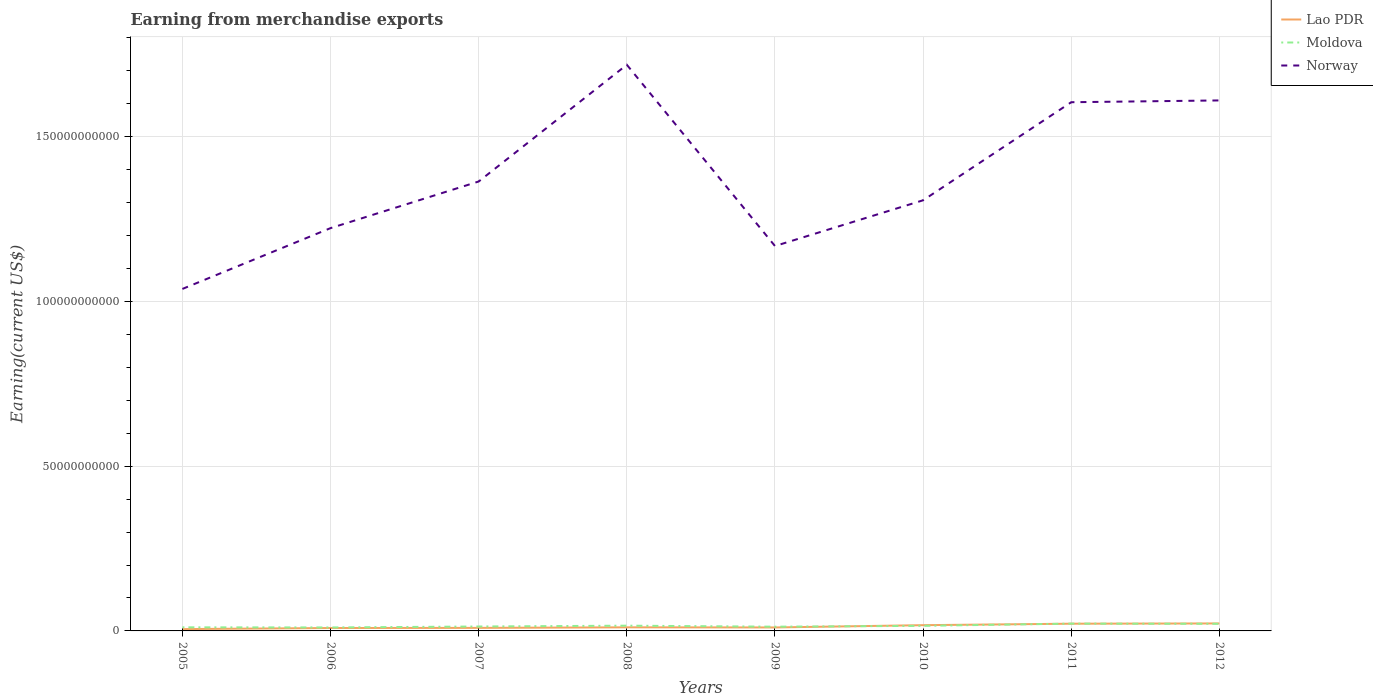Is the number of lines equal to the number of legend labels?
Provide a short and direct response. Yes. Across all years, what is the maximum amount earned from merchandise exports in Moldova?
Your response must be concise. 1.05e+09. What is the total amount earned from merchandise exports in Lao PDR in the graph?
Provide a short and direct response. -1.27e+09. What is the difference between the highest and the second highest amount earned from merchandise exports in Moldova?
Provide a short and direct response. 1.17e+09. Is the amount earned from merchandise exports in Moldova strictly greater than the amount earned from merchandise exports in Norway over the years?
Your response must be concise. Yes. How many lines are there?
Offer a very short reply. 3. How many years are there in the graph?
Provide a short and direct response. 8. How many legend labels are there?
Offer a very short reply. 3. What is the title of the graph?
Your answer should be very brief. Earning from merchandise exports. Does "Greenland" appear as one of the legend labels in the graph?
Keep it short and to the point. No. What is the label or title of the X-axis?
Make the answer very short. Years. What is the label or title of the Y-axis?
Keep it short and to the point. Earning(current US$). What is the Earning(current US$) of Lao PDR in 2005?
Ensure brevity in your answer.  5.53e+08. What is the Earning(current US$) of Moldova in 2005?
Keep it short and to the point. 1.09e+09. What is the Earning(current US$) of Norway in 2005?
Make the answer very short. 1.04e+11. What is the Earning(current US$) of Lao PDR in 2006?
Provide a short and direct response. 8.82e+08. What is the Earning(current US$) of Moldova in 2006?
Provide a short and direct response. 1.05e+09. What is the Earning(current US$) of Norway in 2006?
Give a very brief answer. 1.22e+11. What is the Earning(current US$) of Lao PDR in 2007?
Offer a very short reply. 9.23e+08. What is the Earning(current US$) of Moldova in 2007?
Make the answer very short. 1.34e+09. What is the Earning(current US$) of Norway in 2007?
Ensure brevity in your answer.  1.36e+11. What is the Earning(current US$) of Lao PDR in 2008?
Provide a short and direct response. 1.09e+09. What is the Earning(current US$) of Moldova in 2008?
Give a very brief answer. 1.59e+09. What is the Earning(current US$) in Norway in 2008?
Give a very brief answer. 1.72e+11. What is the Earning(current US$) in Lao PDR in 2009?
Your answer should be compact. 1.05e+09. What is the Earning(current US$) of Moldova in 2009?
Your response must be concise. 1.28e+09. What is the Earning(current US$) of Norway in 2009?
Keep it short and to the point. 1.17e+11. What is the Earning(current US$) of Lao PDR in 2010?
Make the answer very short. 1.75e+09. What is the Earning(current US$) in Moldova in 2010?
Ensure brevity in your answer.  1.54e+09. What is the Earning(current US$) in Norway in 2010?
Ensure brevity in your answer.  1.31e+11. What is the Earning(current US$) of Lao PDR in 2011?
Provide a succinct answer. 2.19e+09. What is the Earning(current US$) of Moldova in 2011?
Ensure brevity in your answer.  2.22e+09. What is the Earning(current US$) of Norway in 2011?
Give a very brief answer. 1.60e+11. What is the Earning(current US$) in Lao PDR in 2012?
Ensure brevity in your answer.  2.27e+09. What is the Earning(current US$) of Moldova in 2012?
Your response must be concise. 2.16e+09. What is the Earning(current US$) of Norway in 2012?
Provide a short and direct response. 1.61e+11. Across all years, what is the maximum Earning(current US$) in Lao PDR?
Make the answer very short. 2.27e+09. Across all years, what is the maximum Earning(current US$) in Moldova?
Ensure brevity in your answer.  2.22e+09. Across all years, what is the maximum Earning(current US$) in Norway?
Keep it short and to the point. 1.72e+11. Across all years, what is the minimum Earning(current US$) of Lao PDR?
Provide a succinct answer. 5.53e+08. Across all years, what is the minimum Earning(current US$) in Moldova?
Give a very brief answer. 1.05e+09. Across all years, what is the minimum Earning(current US$) of Norway?
Your response must be concise. 1.04e+11. What is the total Earning(current US$) in Lao PDR in the graph?
Provide a succinct answer. 1.07e+1. What is the total Earning(current US$) of Moldova in the graph?
Make the answer very short. 1.23e+1. What is the total Earning(current US$) of Norway in the graph?
Your response must be concise. 1.10e+12. What is the difference between the Earning(current US$) in Lao PDR in 2005 and that in 2006?
Provide a succinct answer. -3.29e+08. What is the difference between the Earning(current US$) of Moldova in 2005 and that in 2006?
Offer a very short reply. 3.94e+07. What is the difference between the Earning(current US$) of Norway in 2005 and that in 2006?
Provide a short and direct response. -1.84e+1. What is the difference between the Earning(current US$) in Lao PDR in 2005 and that in 2007?
Give a very brief answer. -3.70e+08. What is the difference between the Earning(current US$) in Moldova in 2005 and that in 2007?
Ensure brevity in your answer.  -2.51e+08. What is the difference between the Earning(current US$) in Norway in 2005 and that in 2007?
Your answer should be compact. -3.26e+1. What is the difference between the Earning(current US$) of Lao PDR in 2005 and that in 2008?
Offer a very short reply. -5.39e+08. What is the difference between the Earning(current US$) in Moldova in 2005 and that in 2008?
Offer a terse response. -5.00e+08. What is the difference between the Earning(current US$) in Norway in 2005 and that in 2008?
Your response must be concise. -6.80e+1. What is the difference between the Earning(current US$) in Lao PDR in 2005 and that in 2009?
Keep it short and to the point. -5.00e+08. What is the difference between the Earning(current US$) in Moldova in 2005 and that in 2009?
Keep it short and to the point. -1.92e+08. What is the difference between the Earning(current US$) of Norway in 2005 and that in 2009?
Your answer should be very brief. -1.30e+1. What is the difference between the Earning(current US$) of Lao PDR in 2005 and that in 2010?
Your answer should be very brief. -1.19e+09. What is the difference between the Earning(current US$) in Moldova in 2005 and that in 2010?
Your response must be concise. -4.50e+08. What is the difference between the Earning(current US$) in Norway in 2005 and that in 2010?
Your answer should be very brief. -2.69e+1. What is the difference between the Earning(current US$) in Lao PDR in 2005 and that in 2011?
Your answer should be very brief. -1.64e+09. What is the difference between the Earning(current US$) of Moldova in 2005 and that in 2011?
Make the answer very short. -1.13e+09. What is the difference between the Earning(current US$) in Norway in 2005 and that in 2011?
Your response must be concise. -5.67e+1. What is the difference between the Earning(current US$) of Lao PDR in 2005 and that in 2012?
Give a very brief answer. -1.72e+09. What is the difference between the Earning(current US$) of Moldova in 2005 and that in 2012?
Provide a succinct answer. -1.07e+09. What is the difference between the Earning(current US$) in Norway in 2005 and that in 2012?
Your answer should be very brief. -5.72e+1. What is the difference between the Earning(current US$) of Lao PDR in 2006 and that in 2007?
Offer a terse response. -4.07e+07. What is the difference between the Earning(current US$) in Moldova in 2006 and that in 2007?
Offer a terse response. -2.90e+08. What is the difference between the Earning(current US$) of Norway in 2006 and that in 2007?
Ensure brevity in your answer.  -1.41e+1. What is the difference between the Earning(current US$) of Lao PDR in 2006 and that in 2008?
Your answer should be compact. -2.10e+08. What is the difference between the Earning(current US$) in Moldova in 2006 and that in 2008?
Provide a short and direct response. -5.40e+08. What is the difference between the Earning(current US$) of Norway in 2006 and that in 2008?
Ensure brevity in your answer.  -4.96e+1. What is the difference between the Earning(current US$) of Lao PDR in 2006 and that in 2009?
Offer a very short reply. -1.71e+08. What is the difference between the Earning(current US$) of Moldova in 2006 and that in 2009?
Offer a very short reply. -2.31e+08. What is the difference between the Earning(current US$) in Norway in 2006 and that in 2009?
Provide a short and direct response. 5.43e+09. What is the difference between the Earning(current US$) of Lao PDR in 2006 and that in 2010?
Ensure brevity in your answer.  -8.64e+08. What is the difference between the Earning(current US$) in Moldova in 2006 and that in 2010?
Give a very brief answer. -4.90e+08. What is the difference between the Earning(current US$) of Norway in 2006 and that in 2010?
Ensure brevity in your answer.  -8.45e+09. What is the difference between the Earning(current US$) in Lao PDR in 2006 and that in 2011?
Provide a short and direct response. -1.31e+09. What is the difference between the Earning(current US$) in Moldova in 2006 and that in 2011?
Offer a very short reply. -1.17e+09. What is the difference between the Earning(current US$) in Norway in 2006 and that in 2011?
Make the answer very short. -3.82e+1. What is the difference between the Earning(current US$) of Lao PDR in 2006 and that in 2012?
Give a very brief answer. -1.39e+09. What is the difference between the Earning(current US$) in Moldova in 2006 and that in 2012?
Provide a short and direct response. -1.11e+09. What is the difference between the Earning(current US$) of Norway in 2006 and that in 2012?
Provide a short and direct response. -3.87e+1. What is the difference between the Earning(current US$) of Lao PDR in 2007 and that in 2008?
Make the answer very short. -1.69e+08. What is the difference between the Earning(current US$) in Moldova in 2007 and that in 2008?
Offer a terse response. -2.50e+08. What is the difference between the Earning(current US$) in Norway in 2007 and that in 2008?
Your response must be concise. -3.54e+1. What is the difference between the Earning(current US$) of Lao PDR in 2007 and that in 2009?
Keep it short and to the point. -1.30e+08. What is the difference between the Earning(current US$) of Moldova in 2007 and that in 2009?
Offer a very short reply. 5.88e+07. What is the difference between the Earning(current US$) in Norway in 2007 and that in 2009?
Provide a succinct answer. 1.96e+1. What is the difference between the Earning(current US$) of Lao PDR in 2007 and that in 2010?
Give a very brief answer. -8.24e+08. What is the difference between the Earning(current US$) in Moldova in 2007 and that in 2010?
Keep it short and to the point. -2.00e+08. What is the difference between the Earning(current US$) of Norway in 2007 and that in 2010?
Provide a succinct answer. 5.70e+09. What is the difference between the Earning(current US$) in Lao PDR in 2007 and that in 2011?
Give a very brief answer. -1.27e+09. What is the difference between the Earning(current US$) in Moldova in 2007 and that in 2011?
Keep it short and to the point. -8.75e+08. What is the difference between the Earning(current US$) of Norway in 2007 and that in 2011?
Keep it short and to the point. -2.41e+1. What is the difference between the Earning(current US$) in Lao PDR in 2007 and that in 2012?
Provide a short and direct response. -1.35e+09. What is the difference between the Earning(current US$) of Moldova in 2007 and that in 2012?
Keep it short and to the point. -8.20e+08. What is the difference between the Earning(current US$) of Norway in 2007 and that in 2012?
Provide a succinct answer. -2.46e+1. What is the difference between the Earning(current US$) in Lao PDR in 2008 and that in 2009?
Ensure brevity in your answer.  3.92e+07. What is the difference between the Earning(current US$) in Moldova in 2008 and that in 2009?
Give a very brief answer. 3.08e+08. What is the difference between the Earning(current US$) in Norway in 2008 and that in 2009?
Offer a terse response. 5.50e+1. What is the difference between the Earning(current US$) of Lao PDR in 2008 and that in 2010?
Ensure brevity in your answer.  -6.54e+08. What is the difference between the Earning(current US$) in Moldova in 2008 and that in 2010?
Make the answer very short. 4.99e+07. What is the difference between the Earning(current US$) in Norway in 2008 and that in 2010?
Keep it short and to the point. 4.11e+1. What is the difference between the Earning(current US$) in Lao PDR in 2008 and that in 2011?
Give a very brief answer. -1.10e+09. What is the difference between the Earning(current US$) of Moldova in 2008 and that in 2011?
Make the answer very short. -6.25e+08. What is the difference between the Earning(current US$) in Norway in 2008 and that in 2011?
Provide a short and direct response. 1.14e+1. What is the difference between the Earning(current US$) in Lao PDR in 2008 and that in 2012?
Keep it short and to the point. -1.18e+09. What is the difference between the Earning(current US$) in Moldova in 2008 and that in 2012?
Offer a terse response. -5.70e+08. What is the difference between the Earning(current US$) of Norway in 2008 and that in 2012?
Provide a short and direct response. 1.08e+1. What is the difference between the Earning(current US$) of Lao PDR in 2009 and that in 2010?
Offer a terse response. -6.94e+08. What is the difference between the Earning(current US$) of Moldova in 2009 and that in 2010?
Provide a succinct answer. -2.59e+08. What is the difference between the Earning(current US$) of Norway in 2009 and that in 2010?
Your answer should be very brief. -1.39e+1. What is the difference between the Earning(current US$) in Lao PDR in 2009 and that in 2011?
Offer a terse response. -1.14e+09. What is the difference between the Earning(current US$) in Moldova in 2009 and that in 2011?
Ensure brevity in your answer.  -9.34e+08. What is the difference between the Earning(current US$) in Norway in 2009 and that in 2011?
Provide a succinct answer. -4.36e+1. What is the difference between the Earning(current US$) in Lao PDR in 2009 and that in 2012?
Ensure brevity in your answer.  -1.22e+09. What is the difference between the Earning(current US$) in Moldova in 2009 and that in 2012?
Provide a short and direct response. -8.79e+08. What is the difference between the Earning(current US$) in Norway in 2009 and that in 2012?
Your answer should be compact. -4.42e+1. What is the difference between the Earning(current US$) of Lao PDR in 2010 and that in 2011?
Provide a succinct answer. -4.43e+08. What is the difference between the Earning(current US$) of Moldova in 2010 and that in 2011?
Your answer should be very brief. -6.75e+08. What is the difference between the Earning(current US$) of Norway in 2010 and that in 2011?
Your response must be concise. -2.98e+1. What is the difference between the Earning(current US$) of Lao PDR in 2010 and that in 2012?
Ensure brevity in your answer.  -5.24e+08. What is the difference between the Earning(current US$) in Moldova in 2010 and that in 2012?
Ensure brevity in your answer.  -6.20e+08. What is the difference between the Earning(current US$) of Norway in 2010 and that in 2012?
Your response must be concise. -3.03e+1. What is the difference between the Earning(current US$) in Lao PDR in 2011 and that in 2012?
Your answer should be compact. -8.11e+07. What is the difference between the Earning(current US$) of Moldova in 2011 and that in 2012?
Your answer should be very brief. 5.49e+07. What is the difference between the Earning(current US$) in Norway in 2011 and that in 2012?
Offer a terse response. -5.42e+08. What is the difference between the Earning(current US$) of Lao PDR in 2005 and the Earning(current US$) of Moldova in 2006?
Ensure brevity in your answer.  -4.99e+08. What is the difference between the Earning(current US$) in Lao PDR in 2005 and the Earning(current US$) in Norway in 2006?
Ensure brevity in your answer.  -1.22e+11. What is the difference between the Earning(current US$) of Moldova in 2005 and the Earning(current US$) of Norway in 2006?
Ensure brevity in your answer.  -1.21e+11. What is the difference between the Earning(current US$) of Lao PDR in 2005 and the Earning(current US$) of Moldova in 2007?
Your answer should be very brief. -7.89e+08. What is the difference between the Earning(current US$) in Lao PDR in 2005 and the Earning(current US$) in Norway in 2007?
Give a very brief answer. -1.36e+11. What is the difference between the Earning(current US$) in Moldova in 2005 and the Earning(current US$) in Norway in 2007?
Your response must be concise. -1.35e+11. What is the difference between the Earning(current US$) of Lao PDR in 2005 and the Earning(current US$) of Moldova in 2008?
Offer a very short reply. -1.04e+09. What is the difference between the Earning(current US$) of Lao PDR in 2005 and the Earning(current US$) of Norway in 2008?
Ensure brevity in your answer.  -1.71e+11. What is the difference between the Earning(current US$) of Moldova in 2005 and the Earning(current US$) of Norway in 2008?
Your response must be concise. -1.71e+11. What is the difference between the Earning(current US$) of Lao PDR in 2005 and the Earning(current US$) of Moldova in 2009?
Ensure brevity in your answer.  -7.30e+08. What is the difference between the Earning(current US$) of Lao PDR in 2005 and the Earning(current US$) of Norway in 2009?
Make the answer very short. -1.16e+11. What is the difference between the Earning(current US$) in Moldova in 2005 and the Earning(current US$) in Norway in 2009?
Offer a very short reply. -1.16e+11. What is the difference between the Earning(current US$) of Lao PDR in 2005 and the Earning(current US$) of Moldova in 2010?
Provide a short and direct response. -9.88e+08. What is the difference between the Earning(current US$) of Lao PDR in 2005 and the Earning(current US$) of Norway in 2010?
Your answer should be compact. -1.30e+11. What is the difference between the Earning(current US$) in Moldova in 2005 and the Earning(current US$) in Norway in 2010?
Your answer should be compact. -1.30e+11. What is the difference between the Earning(current US$) of Lao PDR in 2005 and the Earning(current US$) of Moldova in 2011?
Make the answer very short. -1.66e+09. What is the difference between the Earning(current US$) in Lao PDR in 2005 and the Earning(current US$) in Norway in 2011?
Make the answer very short. -1.60e+11. What is the difference between the Earning(current US$) in Moldova in 2005 and the Earning(current US$) in Norway in 2011?
Give a very brief answer. -1.59e+11. What is the difference between the Earning(current US$) of Lao PDR in 2005 and the Earning(current US$) of Moldova in 2012?
Offer a terse response. -1.61e+09. What is the difference between the Earning(current US$) in Lao PDR in 2005 and the Earning(current US$) in Norway in 2012?
Keep it short and to the point. -1.60e+11. What is the difference between the Earning(current US$) of Moldova in 2005 and the Earning(current US$) of Norway in 2012?
Your response must be concise. -1.60e+11. What is the difference between the Earning(current US$) in Lao PDR in 2006 and the Earning(current US$) in Moldova in 2007?
Offer a terse response. -4.60e+08. What is the difference between the Earning(current US$) in Lao PDR in 2006 and the Earning(current US$) in Norway in 2007?
Ensure brevity in your answer.  -1.35e+11. What is the difference between the Earning(current US$) in Moldova in 2006 and the Earning(current US$) in Norway in 2007?
Make the answer very short. -1.35e+11. What is the difference between the Earning(current US$) of Lao PDR in 2006 and the Earning(current US$) of Moldova in 2008?
Provide a succinct answer. -7.09e+08. What is the difference between the Earning(current US$) of Lao PDR in 2006 and the Earning(current US$) of Norway in 2008?
Offer a very short reply. -1.71e+11. What is the difference between the Earning(current US$) in Moldova in 2006 and the Earning(current US$) in Norway in 2008?
Make the answer very short. -1.71e+11. What is the difference between the Earning(current US$) in Lao PDR in 2006 and the Earning(current US$) in Moldova in 2009?
Your answer should be very brief. -4.01e+08. What is the difference between the Earning(current US$) of Lao PDR in 2006 and the Earning(current US$) of Norway in 2009?
Your answer should be very brief. -1.16e+11. What is the difference between the Earning(current US$) in Moldova in 2006 and the Earning(current US$) in Norway in 2009?
Ensure brevity in your answer.  -1.16e+11. What is the difference between the Earning(current US$) of Lao PDR in 2006 and the Earning(current US$) of Moldova in 2010?
Offer a terse response. -6.59e+08. What is the difference between the Earning(current US$) of Lao PDR in 2006 and the Earning(current US$) of Norway in 2010?
Your answer should be compact. -1.30e+11. What is the difference between the Earning(current US$) in Moldova in 2006 and the Earning(current US$) in Norway in 2010?
Your answer should be compact. -1.30e+11. What is the difference between the Earning(current US$) of Lao PDR in 2006 and the Earning(current US$) of Moldova in 2011?
Your response must be concise. -1.33e+09. What is the difference between the Earning(current US$) in Lao PDR in 2006 and the Earning(current US$) in Norway in 2011?
Provide a short and direct response. -1.60e+11. What is the difference between the Earning(current US$) in Moldova in 2006 and the Earning(current US$) in Norway in 2011?
Your answer should be very brief. -1.59e+11. What is the difference between the Earning(current US$) in Lao PDR in 2006 and the Earning(current US$) in Moldova in 2012?
Provide a short and direct response. -1.28e+09. What is the difference between the Earning(current US$) of Lao PDR in 2006 and the Earning(current US$) of Norway in 2012?
Your response must be concise. -1.60e+11. What is the difference between the Earning(current US$) of Moldova in 2006 and the Earning(current US$) of Norway in 2012?
Keep it short and to the point. -1.60e+11. What is the difference between the Earning(current US$) of Lao PDR in 2007 and the Earning(current US$) of Moldova in 2008?
Your answer should be compact. -6.69e+08. What is the difference between the Earning(current US$) in Lao PDR in 2007 and the Earning(current US$) in Norway in 2008?
Provide a succinct answer. -1.71e+11. What is the difference between the Earning(current US$) in Moldova in 2007 and the Earning(current US$) in Norway in 2008?
Keep it short and to the point. -1.70e+11. What is the difference between the Earning(current US$) of Lao PDR in 2007 and the Earning(current US$) of Moldova in 2009?
Offer a very short reply. -3.60e+08. What is the difference between the Earning(current US$) of Lao PDR in 2007 and the Earning(current US$) of Norway in 2009?
Ensure brevity in your answer.  -1.16e+11. What is the difference between the Earning(current US$) of Moldova in 2007 and the Earning(current US$) of Norway in 2009?
Give a very brief answer. -1.15e+11. What is the difference between the Earning(current US$) of Lao PDR in 2007 and the Earning(current US$) of Moldova in 2010?
Offer a terse response. -6.19e+08. What is the difference between the Earning(current US$) in Lao PDR in 2007 and the Earning(current US$) in Norway in 2010?
Make the answer very short. -1.30e+11. What is the difference between the Earning(current US$) of Moldova in 2007 and the Earning(current US$) of Norway in 2010?
Your answer should be compact. -1.29e+11. What is the difference between the Earning(current US$) of Lao PDR in 2007 and the Earning(current US$) of Moldova in 2011?
Offer a terse response. -1.29e+09. What is the difference between the Earning(current US$) in Lao PDR in 2007 and the Earning(current US$) in Norway in 2011?
Offer a terse response. -1.59e+11. What is the difference between the Earning(current US$) of Moldova in 2007 and the Earning(current US$) of Norway in 2011?
Your answer should be compact. -1.59e+11. What is the difference between the Earning(current US$) of Lao PDR in 2007 and the Earning(current US$) of Moldova in 2012?
Keep it short and to the point. -1.24e+09. What is the difference between the Earning(current US$) of Lao PDR in 2007 and the Earning(current US$) of Norway in 2012?
Give a very brief answer. -1.60e+11. What is the difference between the Earning(current US$) of Moldova in 2007 and the Earning(current US$) of Norway in 2012?
Ensure brevity in your answer.  -1.60e+11. What is the difference between the Earning(current US$) of Lao PDR in 2008 and the Earning(current US$) of Moldova in 2009?
Offer a very short reply. -1.91e+08. What is the difference between the Earning(current US$) of Lao PDR in 2008 and the Earning(current US$) of Norway in 2009?
Ensure brevity in your answer.  -1.16e+11. What is the difference between the Earning(current US$) of Moldova in 2008 and the Earning(current US$) of Norway in 2009?
Your response must be concise. -1.15e+11. What is the difference between the Earning(current US$) of Lao PDR in 2008 and the Earning(current US$) of Moldova in 2010?
Make the answer very short. -4.50e+08. What is the difference between the Earning(current US$) of Lao PDR in 2008 and the Earning(current US$) of Norway in 2010?
Provide a succinct answer. -1.30e+11. What is the difference between the Earning(current US$) of Moldova in 2008 and the Earning(current US$) of Norway in 2010?
Offer a very short reply. -1.29e+11. What is the difference between the Earning(current US$) in Lao PDR in 2008 and the Earning(current US$) in Moldova in 2011?
Give a very brief answer. -1.12e+09. What is the difference between the Earning(current US$) in Lao PDR in 2008 and the Earning(current US$) in Norway in 2011?
Provide a short and direct response. -1.59e+11. What is the difference between the Earning(current US$) of Moldova in 2008 and the Earning(current US$) of Norway in 2011?
Your response must be concise. -1.59e+11. What is the difference between the Earning(current US$) of Lao PDR in 2008 and the Earning(current US$) of Moldova in 2012?
Provide a succinct answer. -1.07e+09. What is the difference between the Earning(current US$) of Lao PDR in 2008 and the Earning(current US$) of Norway in 2012?
Offer a terse response. -1.60e+11. What is the difference between the Earning(current US$) in Moldova in 2008 and the Earning(current US$) in Norway in 2012?
Give a very brief answer. -1.59e+11. What is the difference between the Earning(current US$) in Lao PDR in 2009 and the Earning(current US$) in Moldova in 2010?
Provide a short and direct response. -4.89e+08. What is the difference between the Earning(current US$) in Lao PDR in 2009 and the Earning(current US$) in Norway in 2010?
Give a very brief answer. -1.30e+11. What is the difference between the Earning(current US$) of Moldova in 2009 and the Earning(current US$) of Norway in 2010?
Keep it short and to the point. -1.29e+11. What is the difference between the Earning(current US$) in Lao PDR in 2009 and the Earning(current US$) in Moldova in 2011?
Provide a succinct answer. -1.16e+09. What is the difference between the Earning(current US$) in Lao PDR in 2009 and the Earning(current US$) in Norway in 2011?
Offer a very short reply. -1.59e+11. What is the difference between the Earning(current US$) of Moldova in 2009 and the Earning(current US$) of Norway in 2011?
Make the answer very short. -1.59e+11. What is the difference between the Earning(current US$) in Lao PDR in 2009 and the Earning(current US$) in Moldova in 2012?
Offer a very short reply. -1.11e+09. What is the difference between the Earning(current US$) in Lao PDR in 2009 and the Earning(current US$) in Norway in 2012?
Your answer should be compact. -1.60e+11. What is the difference between the Earning(current US$) in Moldova in 2009 and the Earning(current US$) in Norway in 2012?
Keep it short and to the point. -1.60e+11. What is the difference between the Earning(current US$) in Lao PDR in 2010 and the Earning(current US$) in Moldova in 2011?
Your answer should be very brief. -4.70e+08. What is the difference between the Earning(current US$) of Lao PDR in 2010 and the Earning(current US$) of Norway in 2011?
Offer a very short reply. -1.59e+11. What is the difference between the Earning(current US$) of Moldova in 2010 and the Earning(current US$) of Norway in 2011?
Give a very brief answer. -1.59e+11. What is the difference between the Earning(current US$) in Lao PDR in 2010 and the Earning(current US$) in Moldova in 2012?
Provide a short and direct response. -4.16e+08. What is the difference between the Earning(current US$) of Lao PDR in 2010 and the Earning(current US$) of Norway in 2012?
Provide a short and direct response. -1.59e+11. What is the difference between the Earning(current US$) in Moldova in 2010 and the Earning(current US$) in Norway in 2012?
Give a very brief answer. -1.59e+11. What is the difference between the Earning(current US$) of Lao PDR in 2011 and the Earning(current US$) of Moldova in 2012?
Your answer should be very brief. 2.76e+07. What is the difference between the Earning(current US$) of Lao PDR in 2011 and the Earning(current US$) of Norway in 2012?
Make the answer very short. -1.59e+11. What is the difference between the Earning(current US$) in Moldova in 2011 and the Earning(current US$) in Norway in 2012?
Make the answer very short. -1.59e+11. What is the average Earning(current US$) in Lao PDR per year?
Provide a short and direct response. 1.34e+09. What is the average Earning(current US$) in Moldova per year?
Make the answer very short. 1.53e+09. What is the average Earning(current US$) of Norway per year?
Keep it short and to the point. 1.38e+11. In the year 2005, what is the difference between the Earning(current US$) of Lao PDR and Earning(current US$) of Moldova?
Keep it short and to the point. -5.38e+08. In the year 2005, what is the difference between the Earning(current US$) in Lao PDR and Earning(current US$) in Norway?
Your answer should be very brief. -1.03e+11. In the year 2005, what is the difference between the Earning(current US$) in Moldova and Earning(current US$) in Norway?
Give a very brief answer. -1.03e+11. In the year 2006, what is the difference between the Earning(current US$) in Lao PDR and Earning(current US$) in Moldova?
Your answer should be very brief. -1.70e+08. In the year 2006, what is the difference between the Earning(current US$) in Lao PDR and Earning(current US$) in Norway?
Provide a short and direct response. -1.21e+11. In the year 2006, what is the difference between the Earning(current US$) in Moldova and Earning(current US$) in Norway?
Keep it short and to the point. -1.21e+11. In the year 2007, what is the difference between the Earning(current US$) of Lao PDR and Earning(current US$) of Moldova?
Provide a short and direct response. -4.19e+08. In the year 2007, what is the difference between the Earning(current US$) of Lao PDR and Earning(current US$) of Norway?
Give a very brief answer. -1.35e+11. In the year 2007, what is the difference between the Earning(current US$) in Moldova and Earning(current US$) in Norway?
Keep it short and to the point. -1.35e+11. In the year 2008, what is the difference between the Earning(current US$) in Lao PDR and Earning(current US$) in Moldova?
Offer a terse response. -5.00e+08. In the year 2008, what is the difference between the Earning(current US$) in Lao PDR and Earning(current US$) in Norway?
Provide a succinct answer. -1.71e+11. In the year 2008, what is the difference between the Earning(current US$) of Moldova and Earning(current US$) of Norway?
Your answer should be very brief. -1.70e+11. In the year 2009, what is the difference between the Earning(current US$) in Lao PDR and Earning(current US$) in Moldova?
Provide a succinct answer. -2.30e+08. In the year 2009, what is the difference between the Earning(current US$) in Lao PDR and Earning(current US$) in Norway?
Offer a terse response. -1.16e+11. In the year 2009, what is the difference between the Earning(current US$) in Moldova and Earning(current US$) in Norway?
Make the answer very short. -1.15e+11. In the year 2010, what is the difference between the Earning(current US$) in Lao PDR and Earning(current US$) in Moldova?
Provide a succinct answer. 2.05e+08. In the year 2010, what is the difference between the Earning(current US$) in Lao PDR and Earning(current US$) in Norway?
Ensure brevity in your answer.  -1.29e+11. In the year 2010, what is the difference between the Earning(current US$) in Moldova and Earning(current US$) in Norway?
Provide a short and direct response. -1.29e+11. In the year 2011, what is the difference between the Earning(current US$) of Lao PDR and Earning(current US$) of Moldova?
Provide a succinct answer. -2.72e+07. In the year 2011, what is the difference between the Earning(current US$) in Lao PDR and Earning(current US$) in Norway?
Give a very brief answer. -1.58e+11. In the year 2011, what is the difference between the Earning(current US$) of Moldova and Earning(current US$) of Norway?
Make the answer very short. -1.58e+11. In the year 2012, what is the difference between the Earning(current US$) of Lao PDR and Earning(current US$) of Moldova?
Provide a succinct answer. 1.09e+08. In the year 2012, what is the difference between the Earning(current US$) in Lao PDR and Earning(current US$) in Norway?
Your answer should be compact. -1.59e+11. In the year 2012, what is the difference between the Earning(current US$) in Moldova and Earning(current US$) in Norway?
Provide a short and direct response. -1.59e+11. What is the ratio of the Earning(current US$) of Lao PDR in 2005 to that in 2006?
Your response must be concise. 0.63. What is the ratio of the Earning(current US$) in Moldova in 2005 to that in 2006?
Offer a very short reply. 1.04. What is the ratio of the Earning(current US$) in Norway in 2005 to that in 2006?
Keep it short and to the point. 0.85. What is the ratio of the Earning(current US$) of Lao PDR in 2005 to that in 2007?
Provide a short and direct response. 0.6. What is the ratio of the Earning(current US$) of Moldova in 2005 to that in 2007?
Your answer should be compact. 0.81. What is the ratio of the Earning(current US$) of Norway in 2005 to that in 2007?
Provide a short and direct response. 0.76. What is the ratio of the Earning(current US$) of Lao PDR in 2005 to that in 2008?
Offer a very short reply. 0.51. What is the ratio of the Earning(current US$) of Moldova in 2005 to that in 2008?
Provide a short and direct response. 0.69. What is the ratio of the Earning(current US$) of Norway in 2005 to that in 2008?
Offer a terse response. 0.6. What is the ratio of the Earning(current US$) in Lao PDR in 2005 to that in 2009?
Offer a terse response. 0.53. What is the ratio of the Earning(current US$) in Moldova in 2005 to that in 2009?
Your answer should be very brief. 0.85. What is the ratio of the Earning(current US$) in Norway in 2005 to that in 2009?
Provide a short and direct response. 0.89. What is the ratio of the Earning(current US$) in Lao PDR in 2005 to that in 2010?
Keep it short and to the point. 0.32. What is the ratio of the Earning(current US$) of Moldova in 2005 to that in 2010?
Provide a succinct answer. 0.71. What is the ratio of the Earning(current US$) of Norway in 2005 to that in 2010?
Your response must be concise. 0.79. What is the ratio of the Earning(current US$) of Lao PDR in 2005 to that in 2011?
Ensure brevity in your answer.  0.25. What is the ratio of the Earning(current US$) of Moldova in 2005 to that in 2011?
Give a very brief answer. 0.49. What is the ratio of the Earning(current US$) in Norway in 2005 to that in 2011?
Offer a terse response. 0.65. What is the ratio of the Earning(current US$) of Lao PDR in 2005 to that in 2012?
Offer a terse response. 0.24. What is the ratio of the Earning(current US$) in Moldova in 2005 to that in 2012?
Provide a succinct answer. 0.5. What is the ratio of the Earning(current US$) of Norway in 2005 to that in 2012?
Keep it short and to the point. 0.64. What is the ratio of the Earning(current US$) of Lao PDR in 2006 to that in 2007?
Offer a very short reply. 0.96. What is the ratio of the Earning(current US$) of Moldova in 2006 to that in 2007?
Provide a succinct answer. 0.78. What is the ratio of the Earning(current US$) in Norway in 2006 to that in 2007?
Provide a succinct answer. 0.9. What is the ratio of the Earning(current US$) in Lao PDR in 2006 to that in 2008?
Your answer should be very brief. 0.81. What is the ratio of the Earning(current US$) in Moldova in 2006 to that in 2008?
Offer a terse response. 0.66. What is the ratio of the Earning(current US$) of Norway in 2006 to that in 2008?
Give a very brief answer. 0.71. What is the ratio of the Earning(current US$) in Lao PDR in 2006 to that in 2009?
Provide a succinct answer. 0.84. What is the ratio of the Earning(current US$) of Moldova in 2006 to that in 2009?
Give a very brief answer. 0.82. What is the ratio of the Earning(current US$) in Norway in 2006 to that in 2009?
Your answer should be compact. 1.05. What is the ratio of the Earning(current US$) in Lao PDR in 2006 to that in 2010?
Keep it short and to the point. 0.51. What is the ratio of the Earning(current US$) in Moldova in 2006 to that in 2010?
Your response must be concise. 0.68. What is the ratio of the Earning(current US$) in Norway in 2006 to that in 2010?
Keep it short and to the point. 0.94. What is the ratio of the Earning(current US$) in Lao PDR in 2006 to that in 2011?
Your response must be concise. 0.4. What is the ratio of the Earning(current US$) in Moldova in 2006 to that in 2011?
Provide a succinct answer. 0.47. What is the ratio of the Earning(current US$) of Norway in 2006 to that in 2011?
Offer a terse response. 0.76. What is the ratio of the Earning(current US$) of Lao PDR in 2006 to that in 2012?
Give a very brief answer. 0.39. What is the ratio of the Earning(current US$) in Moldova in 2006 to that in 2012?
Your answer should be very brief. 0.49. What is the ratio of the Earning(current US$) in Norway in 2006 to that in 2012?
Give a very brief answer. 0.76. What is the ratio of the Earning(current US$) in Lao PDR in 2007 to that in 2008?
Your answer should be very brief. 0.84. What is the ratio of the Earning(current US$) of Moldova in 2007 to that in 2008?
Your answer should be very brief. 0.84. What is the ratio of the Earning(current US$) in Norway in 2007 to that in 2008?
Provide a short and direct response. 0.79. What is the ratio of the Earning(current US$) of Lao PDR in 2007 to that in 2009?
Offer a terse response. 0.88. What is the ratio of the Earning(current US$) in Moldova in 2007 to that in 2009?
Offer a terse response. 1.05. What is the ratio of the Earning(current US$) in Norway in 2007 to that in 2009?
Provide a short and direct response. 1.17. What is the ratio of the Earning(current US$) in Lao PDR in 2007 to that in 2010?
Offer a very short reply. 0.53. What is the ratio of the Earning(current US$) in Moldova in 2007 to that in 2010?
Your answer should be very brief. 0.87. What is the ratio of the Earning(current US$) in Norway in 2007 to that in 2010?
Offer a very short reply. 1.04. What is the ratio of the Earning(current US$) of Lao PDR in 2007 to that in 2011?
Offer a terse response. 0.42. What is the ratio of the Earning(current US$) of Moldova in 2007 to that in 2011?
Your answer should be compact. 0.61. What is the ratio of the Earning(current US$) in Norway in 2007 to that in 2011?
Provide a succinct answer. 0.85. What is the ratio of the Earning(current US$) in Lao PDR in 2007 to that in 2012?
Provide a short and direct response. 0.41. What is the ratio of the Earning(current US$) in Moldova in 2007 to that in 2012?
Ensure brevity in your answer.  0.62. What is the ratio of the Earning(current US$) in Norway in 2007 to that in 2012?
Keep it short and to the point. 0.85. What is the ratio of the Earning(current US$) of Lao PDR in 2008 to that in 2009?
Provide a succinct answer. 1.04. What is the ratio of the Earning(current US$) in Moldova in 2008 to that in 2009?
Make the answer very short. 1.24. What is the ratio of the Earning(current US$) in Norway in 2008 to that in 2009?
Ensure brevity in your answer.  1.47. What is the ratio of the Earning(current US$) in Lao PDR in 2008 to that in 2010?
Provide a succinct answer. 0.63. What is the ratio of the Earning(current US$) in Moldova in 2008 to that in 2010?
Give a very brief answer. 1.03. What is the ratio of the Earning(current US$) in Norway in 2008 to that in 2010?
Provide a succinct answer. 1.31. What is the ratio of the Earning(current US$) of Lao PDR in 2008 to that in 2011?
Ensure brevity in your answer.  0.5. What is the ratio of the Earning(current US$) in Moldova in 2008 to that in 2011?
Your answer should be compact. 0.72. What is the ratio of the Earning(current US$) in Norway in 2008 to that in 2011?
Your answer should be compact. 1.07. What is the ratio of the Earning(current US$) of Lao PDR in 2008 to that in 2012?
Ensure brevity in your answer.  0.48. What is the ratio of the Earning(current US$) in Moldova in 2008 to that in 2012?
Your response must be concise. 0.74. What is the ratio of the Earning(current US$) in Norway in 2008 to that in 2012?
Keep it short and to the point. 1.07. What is the ratio of the Earning(current US$) of Lao PDR in 2009 to that in 2010?
Make the answer very short. 0.6. What is the ratio of the Earning(current US$) of Moldova in 2009 to that in 2010?
Give a very brief answer. 0.83. What is the ratio of the Earning(current US$) in Norway in 2009 to that in 2010?
Provide a succinct answer. 0.89. What is the ratio of the Earning(current US$) of Lao PDR in 2009 to that in 2011?
Provide a succinct answer. 0.48. What is the ratio of the Earning(current US$) in Moldova in 2009 to that in 2011?
Your response must be concise. 0.58. What is the ratio of the Earning(current US$) in Norway in 2009 to that in 2011?
Offer a very short reply. 0.73. What is the ratio of the Earning(current US$) of Lao PDR in 2009 to that in 2012?
Ensure brevity in your answer.  0.46. What is the ratio of the Earning(current US$) of Moldova in 2009 to that in 2012?
Offer a terse response. 0.59. What is the ratio of the Earning(current US$) in Norway in 2009 to that in 2012?
Keep it short and to the point. 0.73. What is the ratio of the Earning(current US$) of Lao PDR in 2010 to that in 2011?
Provide a short and direct response. 0.8. What is the ratio of the Earning(current US$) in Moldova in 2010 to that in 2011?
Offer a terse response. 0.7. What is the ratio of the Earning(current US$) in Norway in 2010 to that in 2011?
Provide a succinct answer. 0.81. What is the ratio of the Earning(current US$) of Lao PDR in 2010 to that in 2012?
Offer a very short reply. 0.77. What is the ratio of the Earning(current US$) in Moldova in 2010 to that in 2012?
Ensure brevity in your answer.  0.71. What is the ratio of the Earning(current US$) in Norway in 2010 to that in 2012?
Make the answer very short. 0.81. What is the ratio of the Earning(current US$) in Moldova in 2011 to that in 2012?
Your answer should be very brief. 1.03. What is the difference between the highest and the second highest Earning(current US$) of Lao PDR?
Ensure brevity in your answer.  8.11e+07. What is the difference between the highest and the second highest Earning(current US$) of Moldova?
Provide a short and direct response. 5.49e+07. What is the difference between the highest and the second highest Earning(current US$) of Norway?
Offer a very short reply. 1.08e+1. What is the difference between the highest and the lowest Earning(current US$) of Lao PDR?
Give a very brief answer. 1.72e+09. What is the difference between the highest and the lowest Earning(current US$) in Moldova?
Offer a terse response. 1.17e+09. What is the difference between the highest and the lowest Earning(current US$) in Norway?
Ensure brevity in your answer.  6.80e+1. 